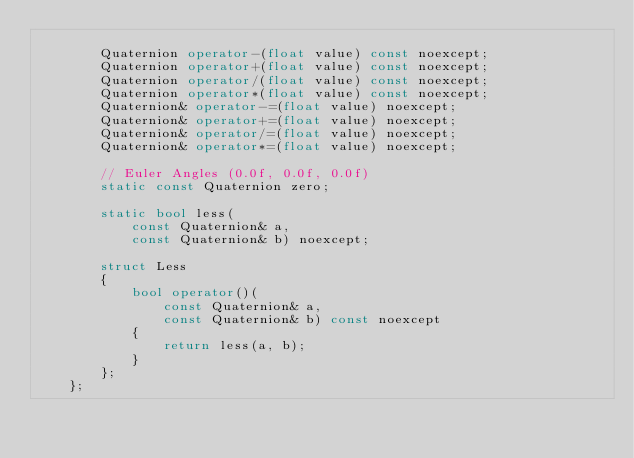<code> <loc_0><loc_0><loc_500><loc_500><_C++_>
		Quaternion operator-(float value) const noexcept;
		Quaternion operator+(float value) const noexcept;
		Quaternion operator/(float value) const noexcept;
		Quaternion operator*(float value) const noexcept;
		Quaternion& operator-=(float value) noexcept;
		Quaternion& operator+=(float value) noexcept;
		Quaternion& operator/=(float value) noexcept;
		Quaternion& operator*=(float value) noexcept;

		// Euler Angles (0.0f, 0.0f, 0.0f)
		static const Quaternion zero;

		static bool less(
			const Quaternion& a,
			const Quaternion& b) noexcept;

		struct Less
		{
			bool operator()(
				const Quaternion& a,
				const Quaternion& b) const noexcept
			{
				return less(a, b);
			}
		};
	};</code> 